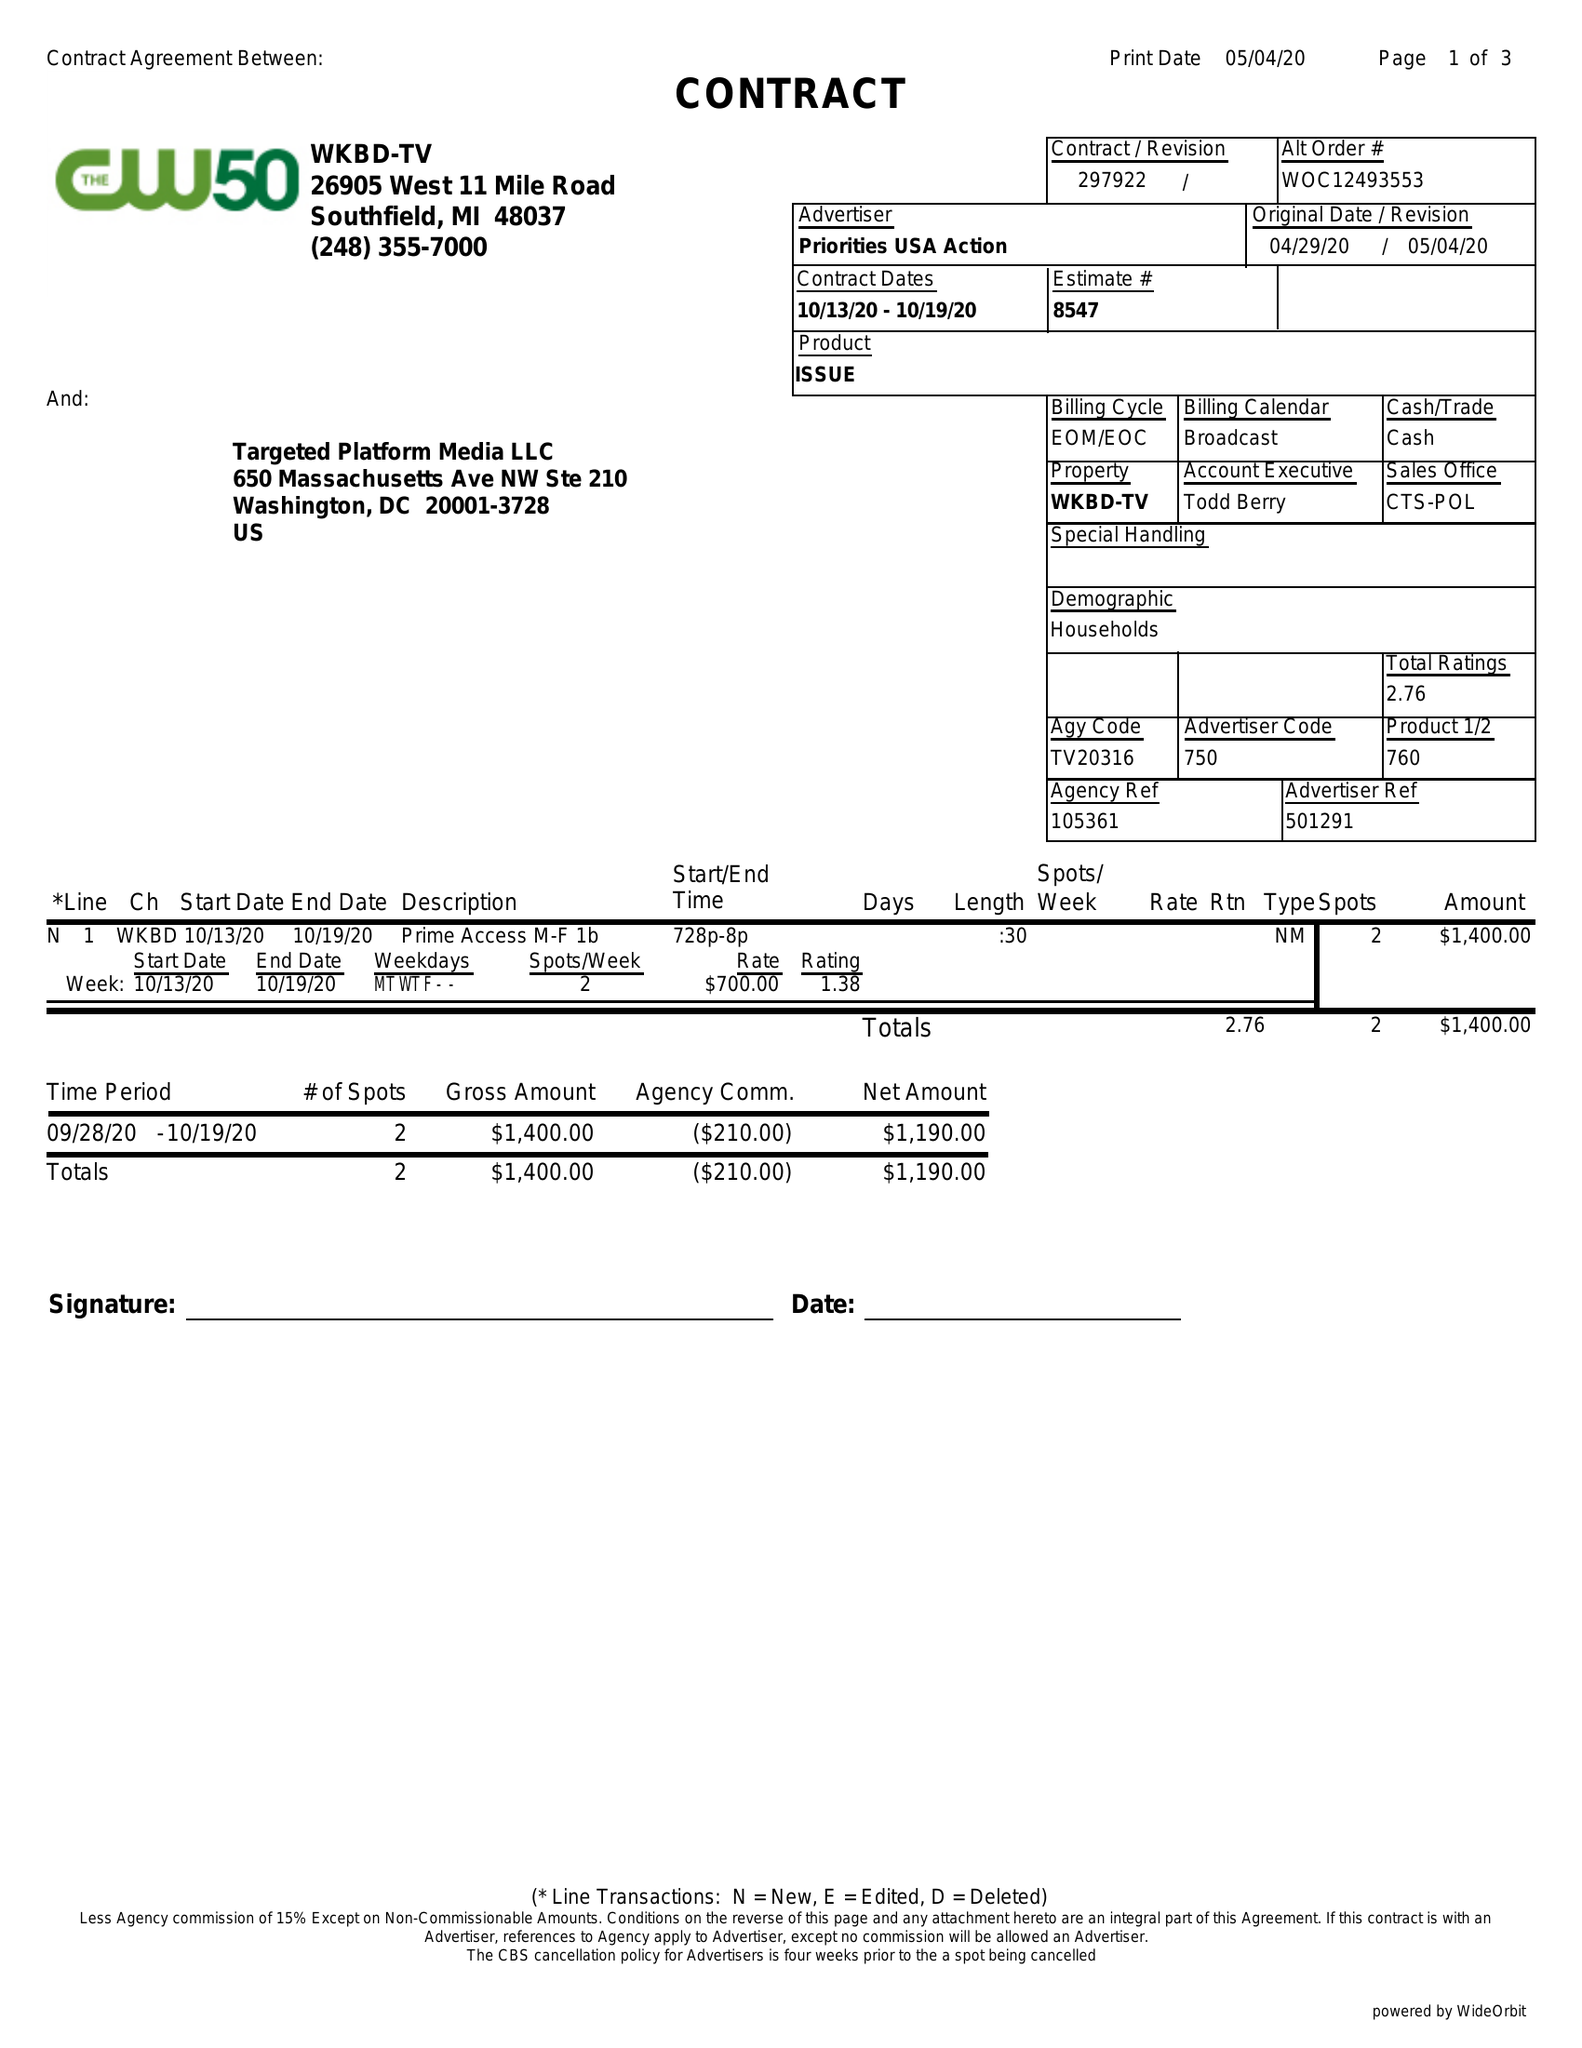What is the value for the gross_amount?
Answer the question using a single word or phrase. 1400.00 